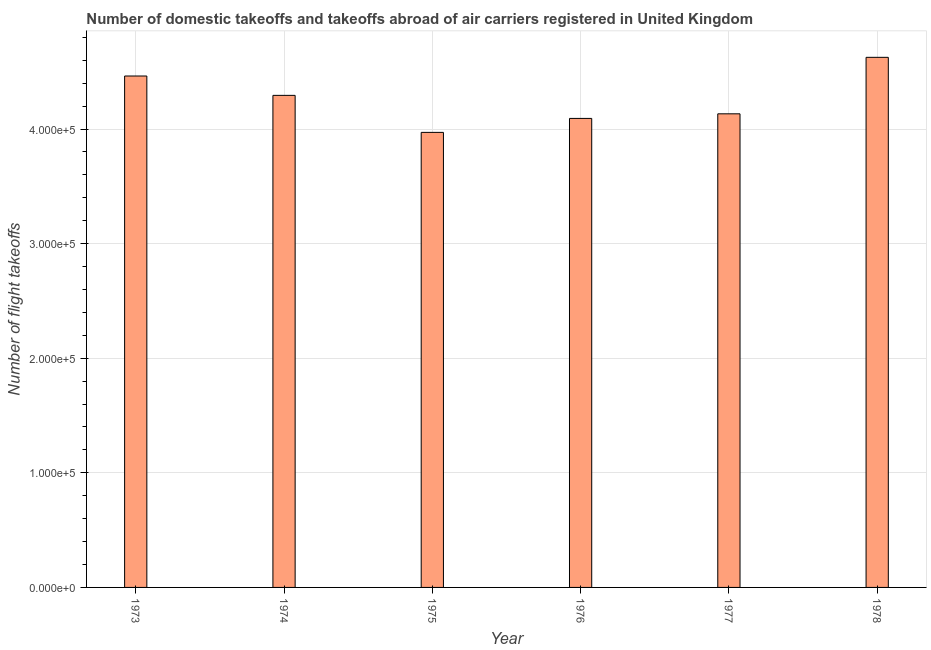Does the graph contain any zero values?
Offer a terse response. No. Does the graph contain grids?
Offer a very short reply. Yes. What is the title of the graph?
Keep it short and to the point. Number of domestic takeoffs and takeoffs abroad of air carriers registered in United Kingdom. What is the label or title of the Y-axis?
Ensure brevity in your answer.  Number of flight takeoffs. What is the number of flight takeoffs in 1974?
Your response must be concise. 4.29e+05. Across all years, what is the maximum number of flight takeoffs?
Keep it short and to the point. 4.63e+05. Across all years, what is the minimum number of flight takeoffs?
Keep it short and to the point. 3.97e+05. In which year was the number of flight takeoffs maximum?
Your answer should be compact. 1978. In which year was the number of flight takeoffs minimum?
Offer a very short reply. 1975. What is the sum of the number of flight takeoffs?
Keep it short and to the point. 2.56e+06. What is the difference between the number of flight takeoffs in 1973 and 1976?
Keep it short and to the point. 3.70e+04. What is the average number of flight takeoffs per year?
Give a very brief answer. 4.26e+05. What is the median number of flight takeoffs?
Provide a short and direct response. 4.21e+05. What is the ratio of the number of flight takeoffs in 1975 to that in 1978?
Provide a succinct answer. 0.86. What is the difference between the highest and the second highest number of flight takeoffs?
Your answer should be very brief. 1.63e+04. Is the sum of the number of flight takeoffs in 1977 and 1978 greater than the maximum number of flight takeoffs across all years?
Your answer should be compact. Yes. What is the difference between the highest and the lowest number of flight takeoffs?
Offer a very short reply. 6.55e+04. In how many years, is the number of flight takeoffs greater than the average number of flight takeoffs taken over all years?
Ensure brevity in your answer.  3. Are all the bars in the graph horizontal?
Give a very brief answer. No. How many years are there in the graph?
Provide a succinct answer. 6. What is the difference between two consecutive major ticks on the Y-axis?
Give a very brief answer. 1.00e+05. Are the values on the major ticks of Y-axis written in scientific E-notation?
Your answer should be very brief. Yes. What is the Number of flight takeoffs of 1973?
Provide a succinct answer. 4.46e+05. What is the Number of flight takeoffs in 1974?
Provide a succinct answer. 4.29e+05. What is the Number of flight takeoffs of 1975?
Your response must be concise. 3.97e+05. What is the Number of flight takeoffs of 1976?
Your answer should be compact. 4.09e+05. What is the Number of flight takeoffs in 1977?
Offer a very short reply. 4.13e+05. What is the Number of flight takeoffs of 1978?
Offer a very short reply. 4.63e+05. What is the difference between the Number of flight takeoffs in 1973 and 1974?
Keep it short and to the point. 1.69e+04. What is the difference between the Number of flight takeoffs in 1973 and 1975?
Provide a succinct answer. 4.92e+04. What is the difference between the Number of flight takeoffs in 1973 and 1976?
Provide a short and direct response. 3.70e+04. What is the difference between the Number of flight takeoffs in 1973 and 1977?
Provide a short and direct response. 3.30e+04. What is the difference between the Number of flight takeoffs in 1973 and 1978?
Ensure brevity in your answer.  -1.63e+04. What is the difference between the Number of flight takeoffs in 1974 and 1975?
Provide a succinct answer. 3.23e+04. What is the difference between the Number of flight takeoffs in 1974 and 1976?
Keep it short and to the point. 2.01e+04. What is the difference between the Number of flight takeoffs in 1974 and 1977?
Provide a succinct answer. 1.61e+04. What is the difference between the Number of flight takeoffs in 1974 and 1978?
Your answer should be very brief. -3.32e+04. What is the difference between the Number of flight takeoffs in 1975 and 1976?
Offer a terse response. -1.22e+04. What is the difference between the Number of flight takeoffs in 1975 and 1977?
Give a very brief answer. -1.62e+04. What is the difference between the Number of flight takeoffs in 1975 and 1978?
Ensure brevity in your answer.  -6.55e+04. What is the difference between the Number of flight takeoffs in 1976 and 1977?
Make the answer very short. -4000. What is the difference between the Number of flight takeoffs in 1976 and 1978?
Provide a succinct answer. -5.33e+04. What is the difference between the Number of flight takeoffs in 1977 and 1978?
Your answer should be compact. -4.93e+04. What is the ratio of the Number of flight takeoffs in 1973 to that in 1974?
Make the answer very short. 1.04. What is the ratio of the Number of flight takeoffs in 1973 to that in 1975?
Give a very brief answer. 1.12. What is the ratio of the Number of flight takeoffs in 1973 to that in 1976?
Your response must be concise. 1.09. What is the ratio of the Number of flight takeoffs in 1974 to that in 1975?
Give a very brief answer. 1.08. What is the ratio of the Number of flight takeoffs in 1974 to that in 1976?
Offer a very short reply. 1.05. What is the ratio of the Number of flight takeoffs in 1974 to that in 1977?
Your answer should be compact. 1.04. What is the ratio of the Number of flight takeoffs in 1974 to that in 1978?
Keep it short and to the point. 0.93. What is the ratio of the Number of flight takeoffs in 1975 to that in 1978?
Your answer should be compact. 0.86. What is the ratio of the Number of flight takeoffs in 1976 to that in 1977?
Your answer should be very brief. 0.99. What is the ratio of the Number of flight takeoffs in 1976 to that in 1978?
Give a very brief answer. 0.89. What is the ratio of the Number of flight takeoffs in 1977 to that in 1978?
Provide a succinct answer. 0.89. 